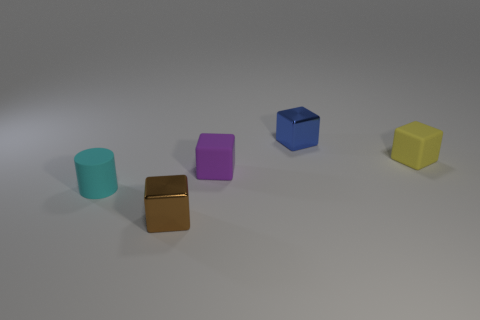Add 3 large cyan metal cylinders. How many objects exist? 8 Subtract all cylinders. How many objects are left? 4 Add 4 tiny shiny blocks. How many tiny shiny blocks exist? 6 Subtract 0 red balls. How many objects are left? 5 Subtract all green blocks. Subtract all small purple cubes. How many objects are left? 4 Add 4 small blue shiny objects. How many small blue shiny objects are left? 5 